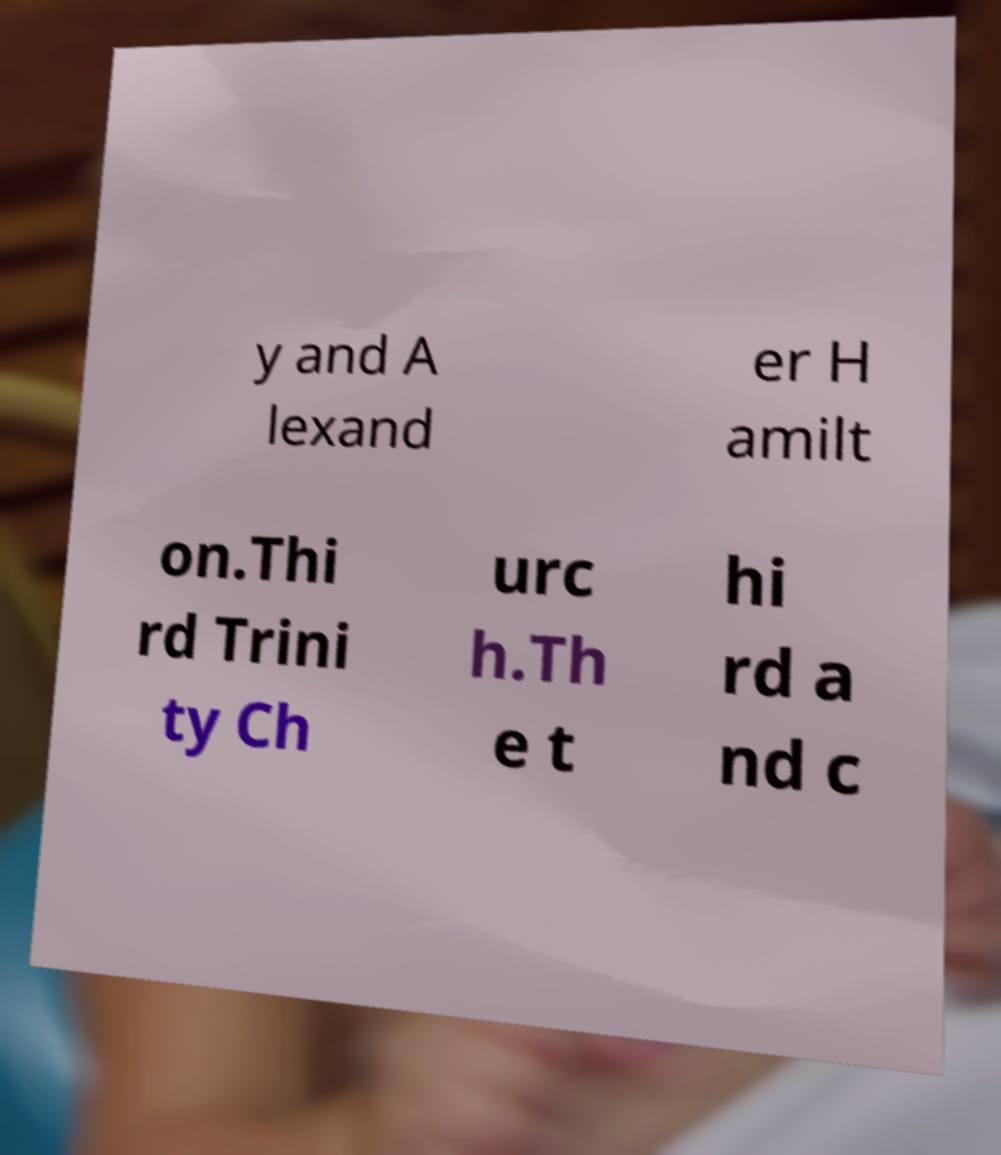Could you extract and type out the text from this image? y and A lexand er H amilt on.Thi rd Trini ty Ch urc h.Th e t hi rd a nd c 